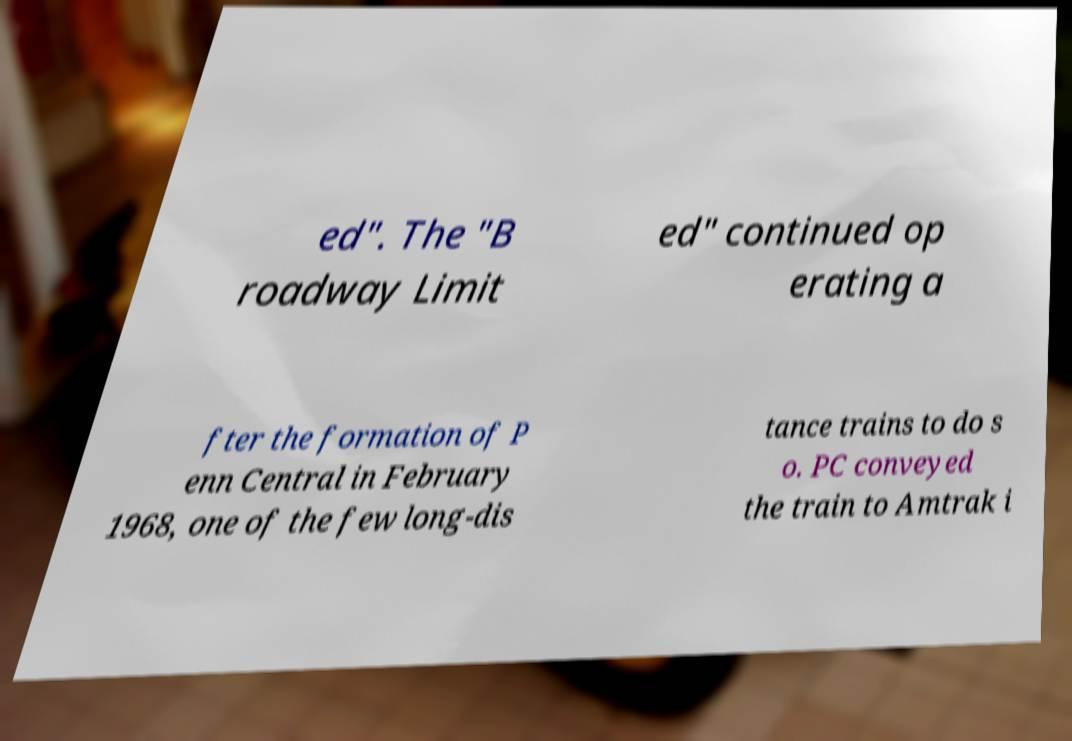Please identify and transcribe the text found in this image. ed". The "B roadway Limit ed" continued op erating a fter the formation of P enn Central in February 1968, one of the few long-dis tance trains to do s o. PC conveyed the train to Amtrak i 